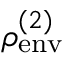Convert formula to latex. <formula><loc_0><loc_0><loc_500><loc_500>\rho _ { e n v } ^ { ( 2 ) }</formula> 